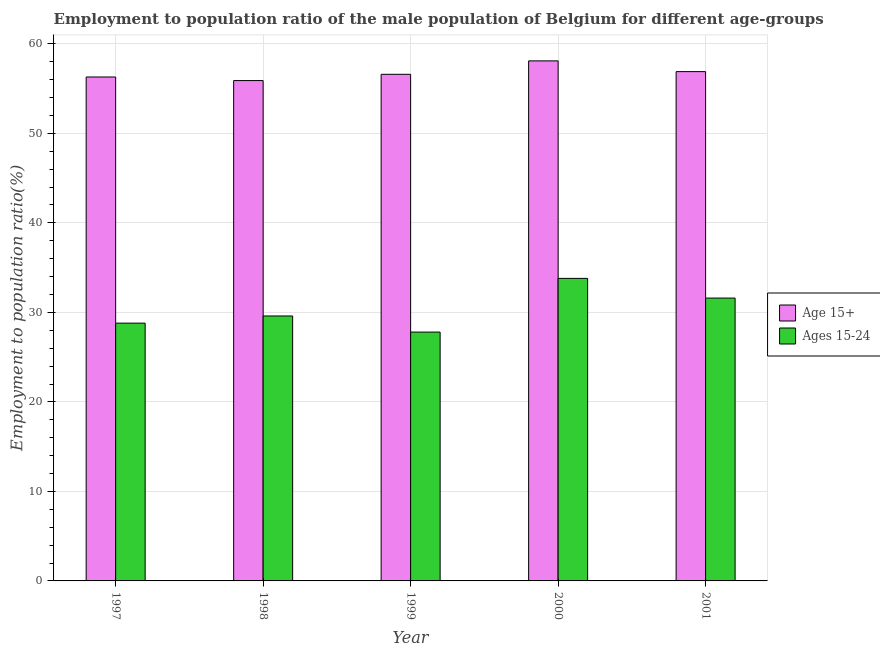Are the number of bars on each tick of the X-axis equal?
Keep it short and to the point. Yes. What is the label of the 4th group of bars from the left?
Provide a short and direct response. 2000. What is the employment to population ratio(age 15+) in 1997?
Your response must be concise. 56.3. Across all years, what is the maximum employment to population ratio(age 15-24)?
Keep it short and to the point. 33.8. Across all years, what is the minimum employment to population ratio(age 15+)?
Give a very brief answer. 55.9. In which year was the employment to population ratio(age 15+) maximum?
Ensure brevity in your answer.  2000. In which year was the employment to population ratio(age 15+) minimum?
Ensure brevity in your answer.  1998. What is the total employment to population ratio(age 15-24) in the graph?
Make the answer very short. 151.6. What is the difference between the employment to population ratio(age 15+) in 1997 and that in 1998?
Offer a terse response. 0.4. What is the difference between the employment to population ratio(age 15+) in 2001 and the employment to population ratio(age 15-24) in 1999?
Provide a short and direct response. 0.3. What is the average employment to population ratio(age 15-24) per year?
Keep it short and to the point. 30.32. In how many years, is the employment to population ratio(age 15+) greater than 52 %?
Provide a succinct answer. 5. What is the ratio of the employment to population ratio(age 15-24) in 1998 to that in 1999?
Offer a very short reply. 1.06. Is the difference between the employment to population ratio(age 15-24) in 1997 and 1998 greater than the difference between the employment to population ratio(age 15+) in 1997 and 1998?
Offer a terse response. No. What is the difference between the highest and the second highest employment to population ratio(age 15-24)?
Ensure brevity in your answer.  2.2. What is the difference between the highest and the lowest employment to population ratio(age 15+)?
Give a very brief answer. 2.2. In how many years, is the employment to population ratio(age 15+) greater than the average employment to population ratio(age 15+) taken over all years?
Provide a short and direct response. 2. What does the 2nd bar from the left in 2001 represents?
Offer a terse response. Ages 15-24. What does the 2nd bar from the right in 1997 represents?
Your response must be concise. Age 15+. How many years are there in the graph?
Provide a succinct answer. 5. Are the values on the major ticks of Y-axis written in scientific E-notation?
Offer a very short reply. No. How many legend labels are there?
Give a very brief answer. 2. How are the legend labels stacked?
Offer a very short reply. Vertical. What is the title of the graph?
Provide a succinct answer. Employment to population ratio of the male population of Belgium for different age-groups. Does "Netherlands" appear as one of the legend labels in the graph?
Offer a terse response. No. What is the label or title of the X-axis?
Your answer should be very brief. Year. What is the Employment to population ratio(%) in Age 15+ in 1997?
Your response must be concise. 56.3. What is the Employment to population ratio(%) in Ages 15-24 in 1997?
Offer a very short reply. 28.8. What is the Employment to population ratio(%) in Age 15+ in 1998?
Offer a terse response. 55.9. What is the Employment to population ratio(%) of Ages 15-24 in 1998?
Your answer should be very brief. 29.6. What is the Employment to population ratio(%) in Age 15+ in 1999?
Offer a terse response. 56.6. What is the Employment to population ratio(%) of Ages 15-24 in 1999?
Give a very brief answer. 27.8. What is the Employment to population ratio(%) in Age 15+ in 2000?
Ensure brevity in your answer.  58.1. What is the Employment to population ratio(%) of Ages 15-24 in 2000?
Give a very brief answer. 33.8. What is the Employment to population ratio(%) in Age 15+ in 2001?
Keep it short and to the point. 56.9. What is the Employment to population ratio(%) in Ages 15-24 in 2001?
Keep it short and to the point. 31.6. Across all years, what is the maximum Employment to population ratio(%) of Age 15+?
Your response must be concise. 58.1. Across all years, what is the maximum Employment to population ratio(%) of Ages 15-24?
Make the answer very short. 33.8. Across all years, what is the minimum Employment to population ratio(%) of Age 15+?
Your answer should be compact. 55.9. Across all years, what is the minimum Employment to population ratio(%) of Ages 15-24?
Offer a terse response. 27.8. What is the total Employment to population ratio(%) of Age 15+ in the graph?
Provide a succinct answer. 283.8. What is the total Employment to population ratio(%) in Ages 15-24 in the graph?
Your answer should be very brief. 151.6. What is the difference between the Employment to population ratio(%) in Age 15+ in 1997 and that in 1998?
Give a very brief answer. 0.4. What is the difference between the Employment to population ratio(%) of Ages 15-24 in 1997 and that in 1998?
Offer a very short reply. -0.8. What is the difference between the Employment to population ratio(%) of Age 15+ in 1997 and that in 2000?
Keep it short and to the point. -1.8. What is the difference between the Employment to population ratio(%) in Ages 15-24 in 1997 and that in 2000?
Offer a terse response. -5. What is the difference between the Employment to population ratio(%) of Age 15+ in 1998 and that in 1999?
Provide a succinct answer. -0.7. What is the difference between the Employment to population ratio(%) in Ages 15-24 in 1998 and that in 2000?
Provide a short and direct response. -4.2. What is the difference between the Employment to population ratio(%) in Age 15+ in 1998 and that in 2001?
Make the answer very short. -1. What is the difference between the Employment to population ratio(%) of Ages 15-24 in 1998 and that in 2001?
Your answer should be very brief. -2. What is the difference between the Employment to population ratio(%) of Ages 15-24 in 1999 and that in 2001?
Your response must be concise. -3.8. What is the difference between the Employment to population ratio(%) of Age 15+ in 1997 and the Employment to population ratio(%) of Ages 15-24 in 1998?
Ensure brevity in your answer.  26.7. What is the difference between the Employment to population ratio(%) in Age 15+ in 1997 and the Employment to population ratio(%) in Ages 15-24 in 2001?
Provide a short and direct response. 24.7. What is the difference between the Employment to population ratio(%) of Age 15+ in 1998 and the Employment to population ratio(%) of Ages 15-24 in 1999?
Make the answer very short. 28.1. What is the difference between the Employment to population ratio(%) in Age 15+ in 1998 and the Employment to population ratio(%) in Ages 15-24 in 2000?
Your answer should be very brief. 22.1. What is the difference between the Employment to population ratio(%) of Age 15+ in 1998 and the Employment to population ratio(%) of Ages 15-24 in 2001?
Provide a succinct answer. 24.3. What is the difference between the Employment to population ratio(%) of Age 15+ in 1999 and the Employment to population ratio(%) of Ages 15-24 in 2000?
Make the answer very short. 22.8. What is the difference between the Employment to population ratio(%) in Age 15+ in 1999 and the Employment to population ratio(%) in Ages 15-24 in 2001?
Offer a terse response. 25. What is the difference between the Employment to population ratio(%) in Age 15+ in 2000 and the Employment to population ratio(%) in Ages 15-24 in 2001?
Offer a very short reply. 26.5. What is the average Employment to population ratio(%) of Age 15+ per year?
Offer a very short reply. 56.76. What is the average Employment to population ratio(%) in Ages 15-24 per year?
Give a very brief answer. 30.32. In the year 1997, what is the difference between the Employment to population ratio(%) of Age 15+ and Employment to population ratio(%) of Ages 15-24?
Make the answer very short. 27.5. In the year 1998, what is the difference between the Employment to population ratio(%) of Age 15+ and Employment to population ratio(%) of Ages 15-24?
Offer a very short reply. 26.3. In the year 1999, what is the difference between the Employment to population ratio(%) in Age 15+ and Employment to population ratio(%) in Ages 15-24?
Make the answer very short. 28.8. In the year 2000, what is the difference between the Employment to population ratio(%) in Age 15+ and Employment to population ratio(%) in Ages 15-24?
Keep it short and to the point. 24.3. In the year 2001, what is the difference between the Employment to population ratio(%) of Age 15+ and Employment to population ratio(%) of Ages 15-24?
Provide a short and direct response. 25.3. What is the ratio of the Employment to population ratio(%) in Age 15+ in 1997 to that in 1999?
Provide a succinct answer. 0.99. What is the ratio of the Employment to population ratio(%) in Ages 15-24 in 1997 to that in 1999?
Offer a terse response. 1.04. What is the ratio of the Employment to population ratio(%) in Ages 15-24 in 1997 to that in 2000?
Your response must be concise. 0.85. What is the ratio of the Employment to population ratio(%) in Ages 15-24 in 1997 to that in 2001?
Provide a short and direct response. 0.91. What is the ratio of the Employment to population ratio(%) of Age 15+ in 1998 to that in 1999?
Offer a terse response. 0.99. What is the ratio of the Employment to population ratio(%) in Ages 15-24 in 1998 to that in 1999?
Your answer should be compact. 1.06. What is the ratio of the Employment to population ratio(%) in Age 15+ in 1998 to that in 2000?
Keep it short and to the point. 0.96. What is the ratio of the Employment to population ratio(%) of Ages 15-24 in 1998 to that in 2000?
Give a very brief answer. 0.88. What is the ratio of the Employment to population ratio(%) of Age 15+ in 1998 to that in 2001?
Offer a very short reply. 0.98. What is the ratio of the Employment to population ratio(%) of Ages 15-24 in 1998 to that in 2001?
Your response must be concise. 0.94. What is the ratio of the Employment to population ratio(%) of Age 15+ in 1999 to that in 2000?
Give a very brief answer. 0.97. What is the ratio of the Employment to population ratio(%) of Ages 15-24 in 1999 to that in 2000?
Provide a succinct answer. 0.82. What is the ratio of the Employment to population ratio(%) of Ages 15-24 in 1999 to that in 2001?
Ensure brevity in your answer.  0.88. What is the ratio of the Employment to population ratio(%) of Age 15+ in 2000 to that in 2001?
Offer a terse response. 1.02. What is the ratio of the Employment to population ratio(%) in Ages 15-24 in 2000 to that in 2001?
Your answer should be compact. 1.07. What is the difference between the highest and the second highest Employment to population ratio(%) of Ages 15-24?
Ensure brevity in your answer.  2.2. What is the difference between the highest and the lowest Employment to population ratio(%) of Age 15+?
Offer a terse response. 2.2. 